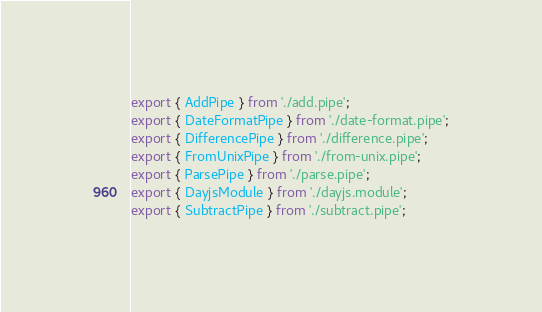Convert code to text. <code><loc_0><loc_0><loc_500><loc_500><_TypeScript_>export { AddPipe } from './add.pipe';
export { DateFormatPipe } from './date-format.pipe';
export { DifferencePipe } from './difference.pipe';
export { FromUnixPipe } from './from-unix.pipe';
export { ParsePipe } from './parse.pipe';
export { DayjsModule } from './dayjs.module';
export { SubtractPipe } from './subtract.pipe';
</code> 